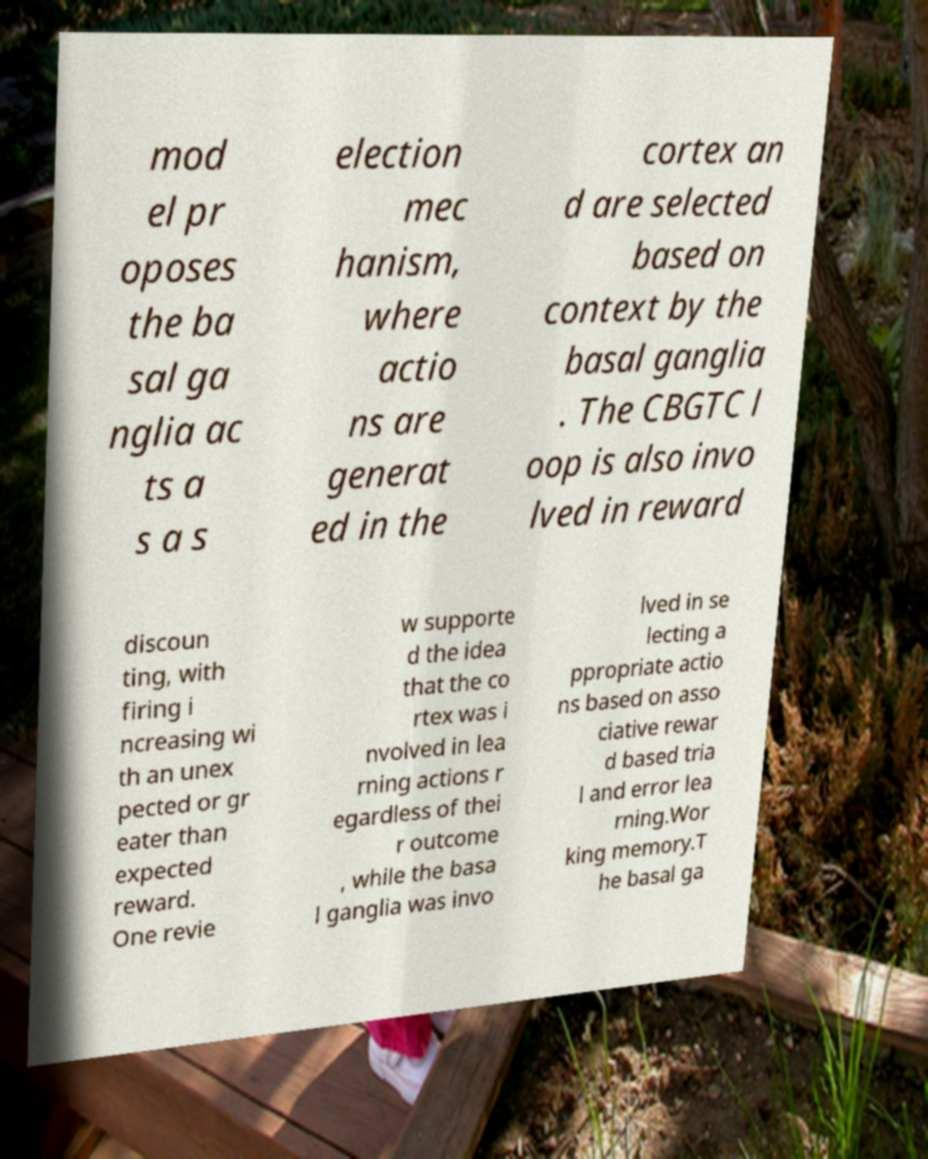What messages or text are displayed in this image? I need them in a readable, typed format. mod el pr oposes the ba sal ga nglia ac ts a s a s election mec hanism, where actio ns are generat ed in the cortex an d are selected based on context by the basal ganglia . The CBGTC l oop is also invo lved in reward discoun ting, with firing i ncreasing wi th an unex pected or gr eater than expected reward. One revie w supporte d the idea that the co rtex was i nvolved in lea rning actions r egardless of thei r outcome , while the basa l ganglia was invo lved in se lecting a ppropriate actio ns based on asso ciative rewar d based tria l and error lea rning.Wor king memory.T he basal ga 